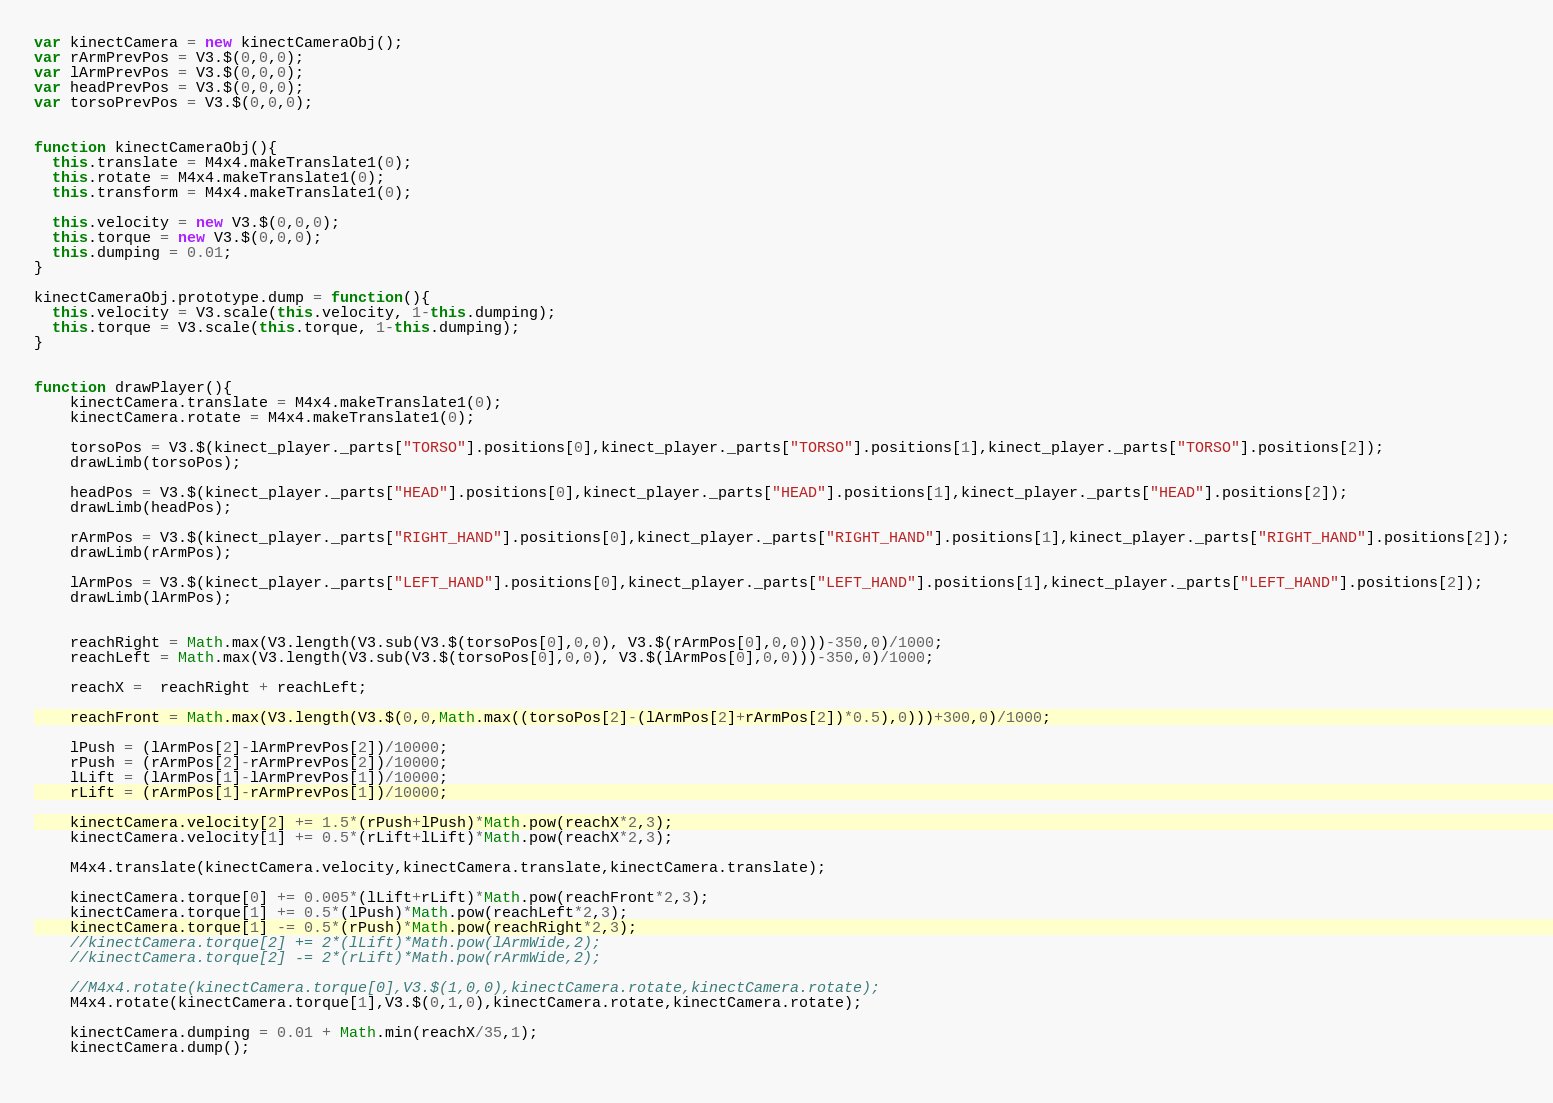<code> <loc_0><loc_0><loc_500><loc_500><_JavaScript_>var kinectCamera = new kinectCameraObj();
var rArmPrevPos = V3.$(0,0,0);
var lArmPrevPos = V3.$(0,0,0);
var headPrevPos = V3.$(0,0,0);
var torsoPrevPos = V3.$(0,0,0);


function kinectCameraObj(){
  this.translate = M4x4.makeTranslate1(0);
  this.rotate = M4x4.makeTranslate1(0);
  this.transform = M4x4.makeTranslate1(0);

  this.velocity = new V3.$(0,0,0);
  this.torque = new V3.$(0,0,0);
  this.dumping = 0.01;
}

kinectCameraObj.prototype.dump = function(){
  this.velocity = V3.scale(this.velocity, 1-this.dumping);
  this.torque = V3.scale(this.torque, 1-this.dumping);
}


function drawPlayer(){ 
	kinectCamera.translate = M4x4.makeTranslate1(0);
	kinectCamera.rotate = M4x4.makeTranslate1(0);
	
	torsoPos = V3.$(kinect_player._parts["TORSO"].positions[0],kinect_player._parts["TORSO"].positions[1],kinect_player._parts["TORSO"].positions[2]); 
	drawLimb(torsoPos);

	headPos = V3.$(kinect_player._parts["HEAD"].positions[0],kinect_player._parts["HEAD"].positions[1],kinect_player._parts["HEAD"].positions[2]); 
	drawLimb(headPos);	
	
	rArmPos = V3.$(kinect_player._parts["RIGHT_HAND"].positions[0],kinect_player._parts["RIGHT_HAND"].positions[1],kinect_player._parts["RIGHT_HAND"].positions[2]); 
	drawLimb(rArmPos);	

	lArmPos = V3.$(kinect_player._parts["LEFT_HAND"].positions[0],kinect_player._parts["LEFT_HAND"].positions[1],kinect_player._parts["LEFT_HAND"].positions[2]); 
	drawLimb(lArmPos);		
	
	
	reachRight = Math.max(V3.length(V3.sub(V3.$(torsoPos[0],0,0), V3.$(rArmPos[0],0,0)))-350,0)/1000;
	reachLeft = Math.max(V3.length(V3.sub(V3.$(torsoPos[0],0,0), V3.$(lArmPos[0],0,0)))-350,0)/1000;
	
	reachX =  reachRight + reachLeft;
	
	reachFront = Math.max(V3.length(V3.$(0,0,Math.max((torsoPos[2]-(lArmPos[2]+rArmPos[2])*0.5),0)))+300,0)/1000;
	
	lPush = (lArmPos[2]-lArmPrevPos[2])/10000;
	rPush = (rArmPos[2]-rArmPrevPos[2])/10000;
	lLift = (lArmPos[1]-lArmPrevPos[1])/10000;
	rLift = (rArmPos[1]-rArmPrevPos[1])/10000;
	
	kinectCamera.velocity[2] += 1.5*(rPush+lPush)*Math.pow(reachX*2,3);
	kinectCamera.velocity[1] += 0.5*(rLift+lLift)*Math.pow(reachX*2,3);	
	
	M4x4.translate(kinectCamera.velocity,kinectCamera.translate,kinectCamera.translate);
	
	kinectCamera.torque[0] += 0.005*(lLift+rLift)*Math.pow(reachFront*2,3);
	kinectCamera.torque[1] += 0.5*(lPush)*Math.pow(reachLeft*2,3);
	kinectCamera.torque[1] -= 0.5*(rPush)*Math.pow(reachRight*2,3);
	//kinectCamera.torque[2] += 2*(lLift)*Math.pow(lArmWide,2);
	//kinectCamera.torque[2] -= 2*(rLift)*Math.pow(rArmWide,2);
		
	//M4x4.rotate(kinectCamera.torque[0],V3.$(1,0,0),kinectCamera.rotate,kinectCamera.rotate);
	M4x4.rotate(kinectCamera.torque[1],V3.$(0,1,0),kinectCamera.rotate,kinectCamera.rotate);

	kinectCamera.dumping = 0.01 + Math.min(reachX/35,1);
	kinectCamera.dump();
	</code> 